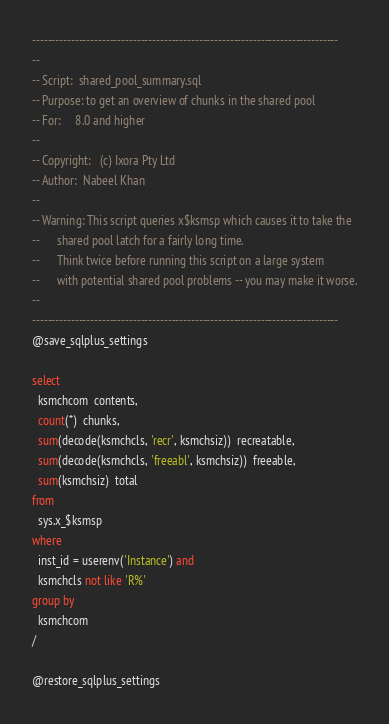<code> <loc_0><loc_0><loc_500><loc_500><_SQL_>-------------------------------------------------------------------------------
--
-- Script:	shared_pool_summary.sql
-- Purpose:	to get an overview of chunks in the shared pool
-- For:		8.0 and higher
--
-- Copyright:	(c) Ixora Pty Ltd
-- Author:	Nabeel Khan
--
-- Warning:	This script queries x$ksmsp which causes it to take the
--		shared pool latch for a fairly long time.
--		Think twice before running this script on a large system
--		with potential shared pool problems -- you may make it worse.
--
-------------------------------------------------------------------------------
@save_sqlplus_settings

select
  ksmchcom  contents,
  count(*)  chunks,
  sum(decode(ksmchcls, 'recr', ksmchsiz))  recreatable,
  sum(decode(ksmchcls, 'freeabl', ksmchsiz))  freeable,
  sum(ksmchsiz)  total
from
  sys.x_$ksmsp
where
  inst_id = userenv('Instance') and
  ksmchcls not like 'R%'
group by
  ksmchcom
/

@restore_sqlplus_settings
</code> 